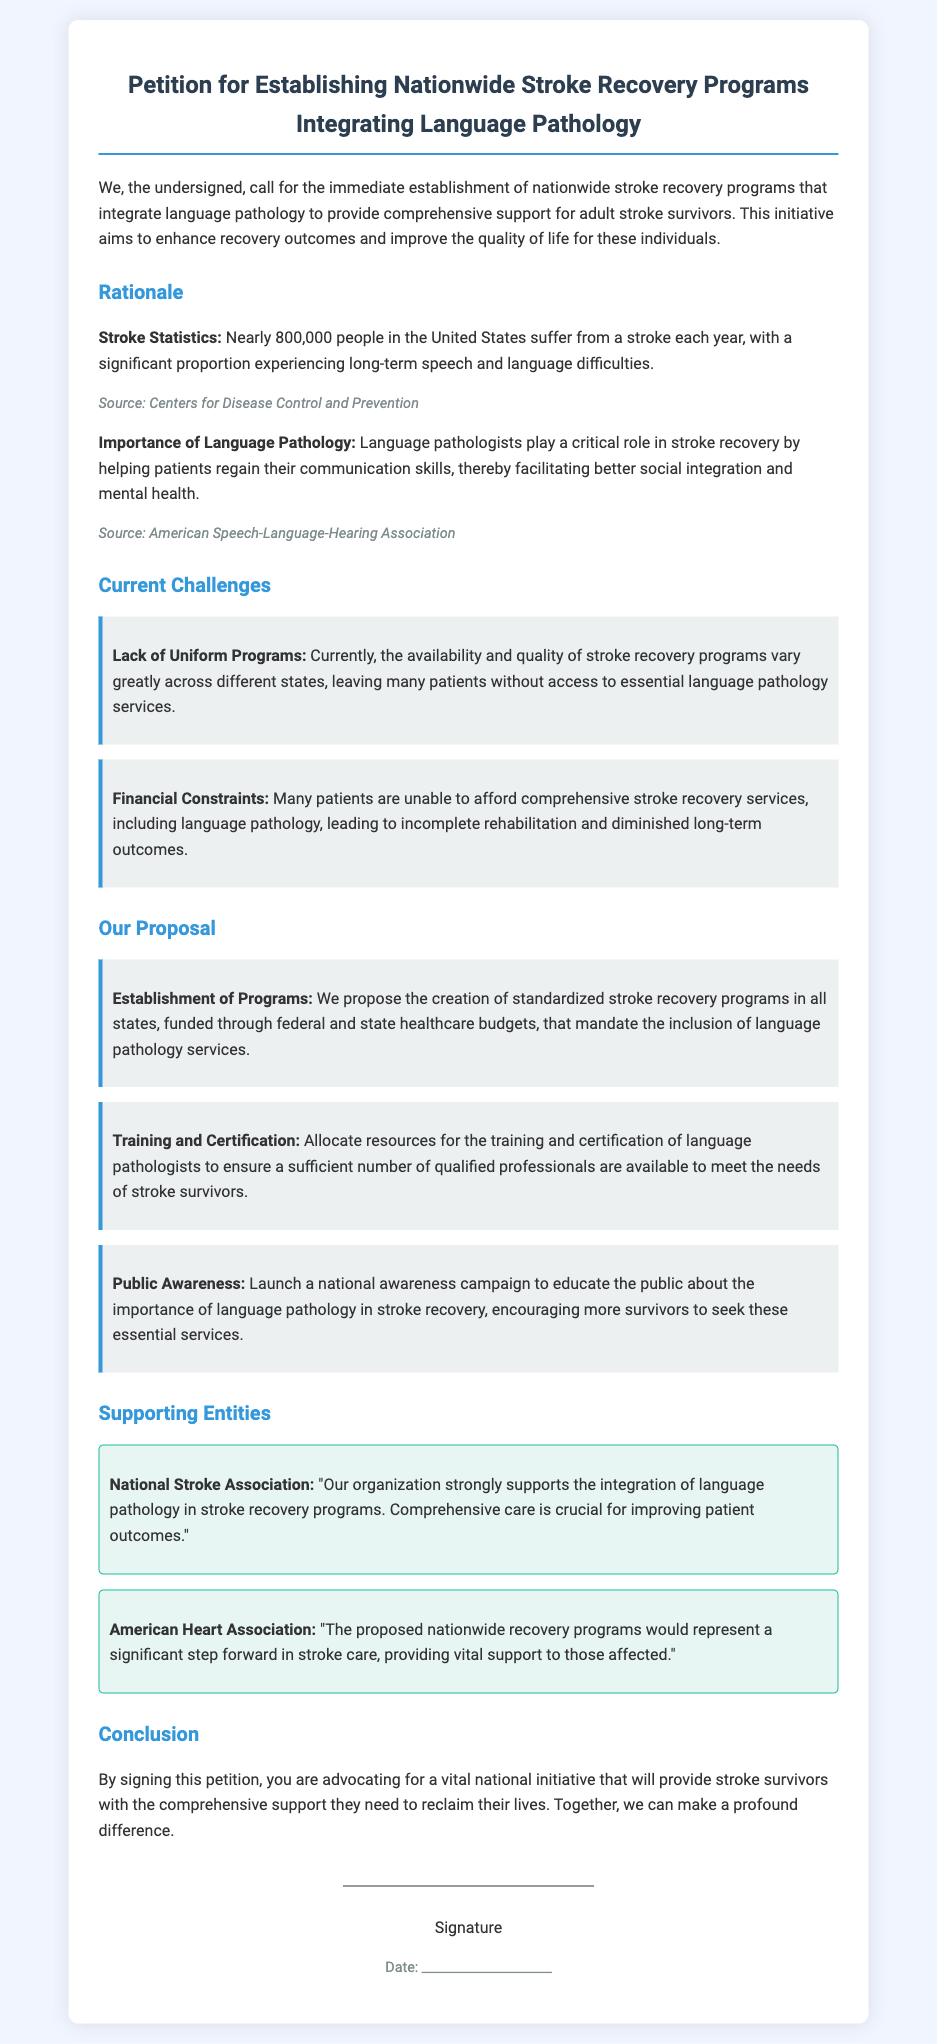What is the title of the petition? The title of the petition is presented at the top of the document.
Answer: Petition for Establishing Nationwide Stroke Recovery Programs Integrating Language Pathology How many people in the U.S. suffer from a stroke each year? The petition cites a specific statistic regarding stroke occurrences in the United States.
Answer: Nearly 800,000 What are the two main current challenges outlined? The challenges listed in the document address the issues faced by stroke recovery programs.
Answer: Lack of Uniform Programs, Financial Constraints What does the proposal recommend for training language pathologists? The document includes a specific recommendation related to the training of language pathologists.
Answer: Allocate resources for the training and certification Which organization supports the integration of language pathology? The supporting entities section mentions organizations that endorse the petition's goals.
Answer: National Stroke Association What is the main goal of the national awareness campaign proposed? The campaign's purpose is clearly stated in the document.
Answer: Educate the public about the importance of language pathology in stroke recovery What do the signatures represent in this document? The signature area signifies participation in the petition.
Answer: Advocating for a vital national initiative Which two organizations are mentioned as supporting entities? The document lists specific organizations that back the proposal.
Answer: National Stroke Association, American Heart Association 